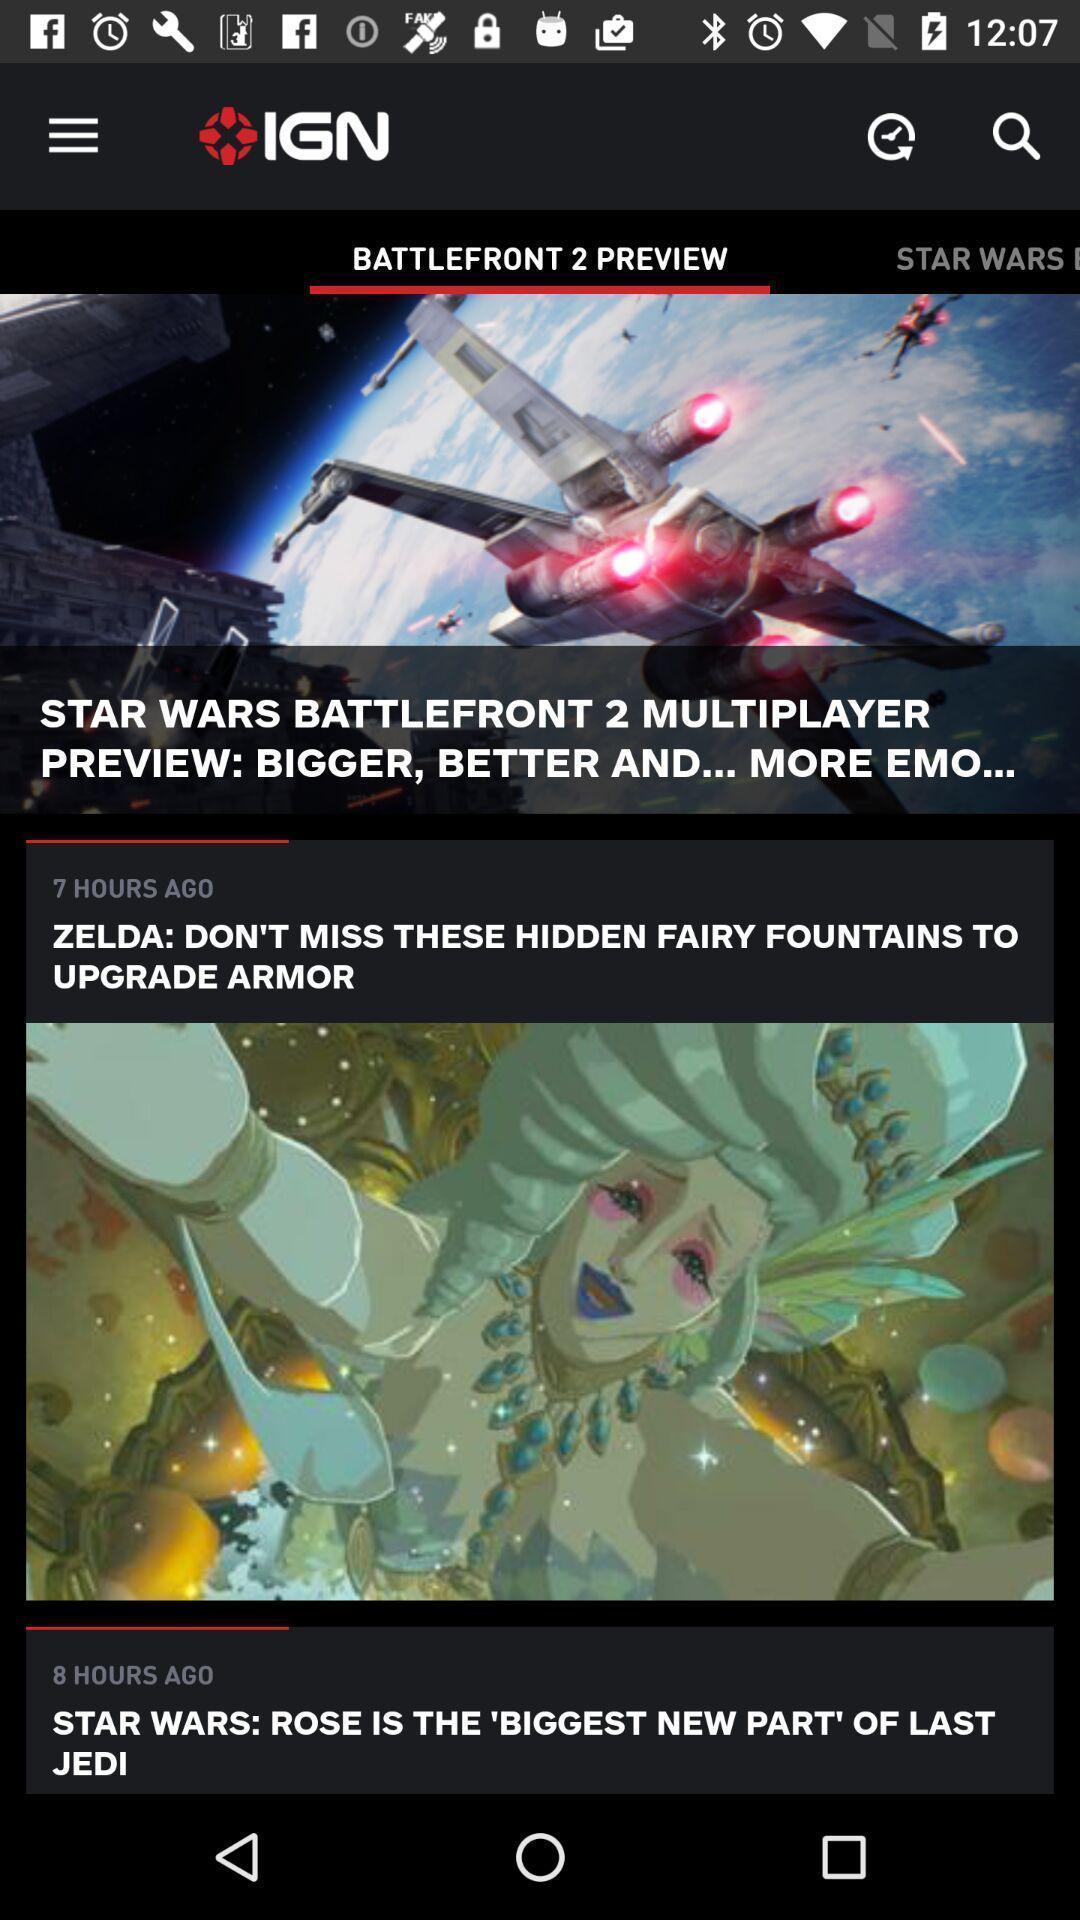Provide a textual representation of this image. Window displaying video game news. 